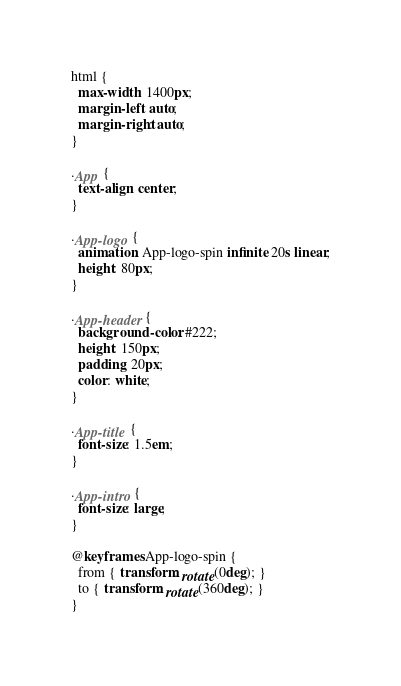Convert code to text. <code><loc_0><loc_0><loc_500><loc_500><_CSS_>html {
  max-width: 1400px;
  margin-left: auto;
  margin-right: auto;
}

.App {
  text-align: center;
}

.App-logo {
  animation: App-logo-spin infinite 20s linear;
  height: 80px;
}

.App-header {
  background-color: #222;
  height: 150px;
  padding: 20px;
  color: white;
}

.App-title {
  font-size: 1.5em;
}

.App-intro {
  font-size: large;
}

@keyframes App-logo-spin {
  from { transform: rotate(0deg); }
  to { transform: rotate(360deg); }
}
</code> 